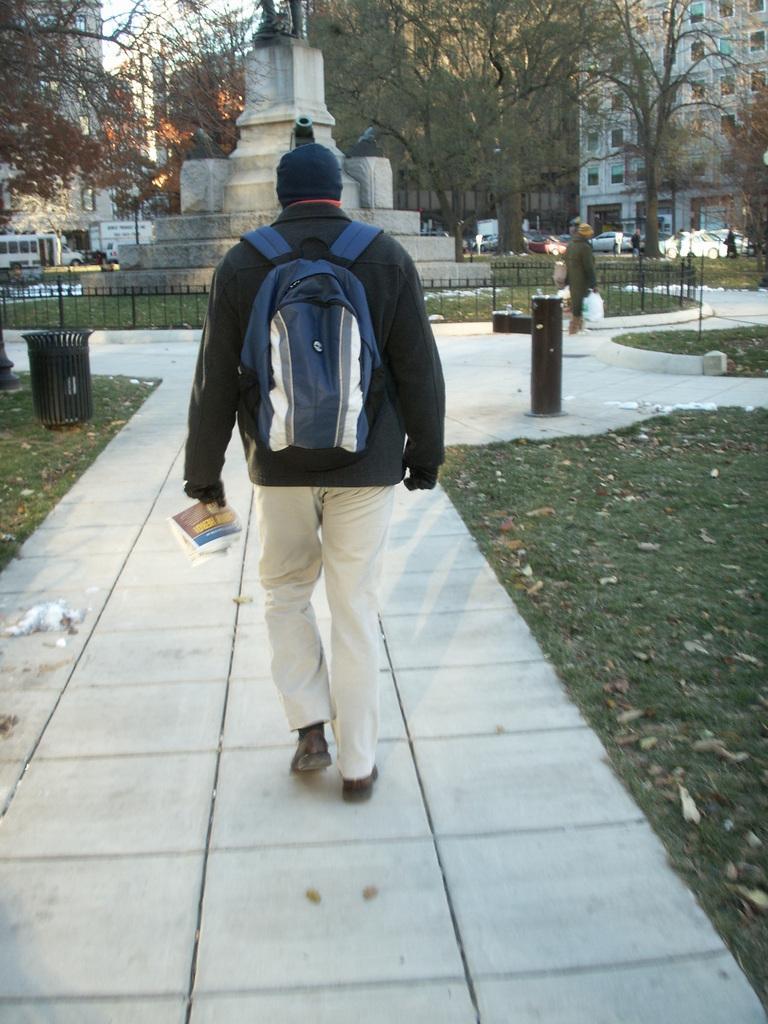Could you give a brief overview of what you see in this image? In this image I can see a man wearing a backpack bag,holding newspaper on his hand and walking along the pathway. At background I can see big buildings and huge trees. I can see cars and some other vehicles parking. I can see a person walking. At the left of the image I can see a dustbin. At background,at the left corner of the image I can see a vehicle 